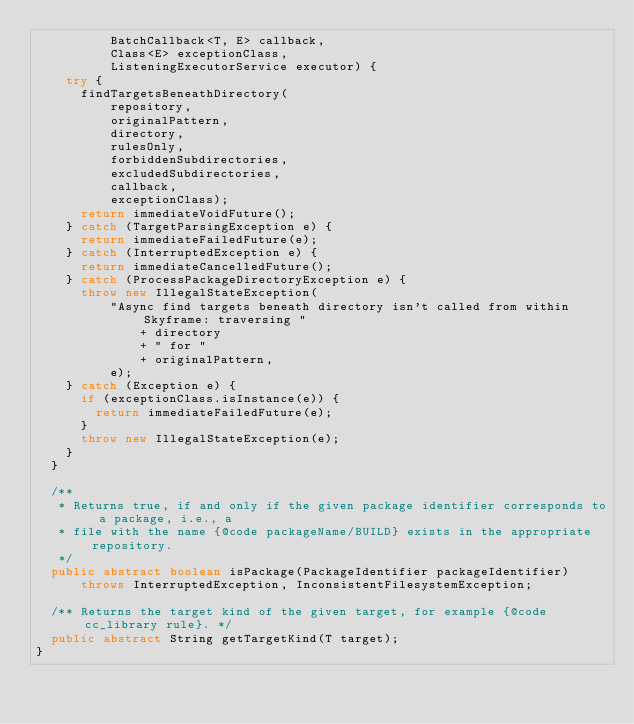Convert code to text. <code><loc_0><loc_0><loc_500><loc_500><_Java_>          BatchCallback<T, E> callback,
          Class<E> exceptionClass,
          ListeningExecutorService executor) {
    try {
      findTargetsBeneathDirectory(
          repository,
          originalPattern,
          directory,
          rulesOnly,
          forbiddenSubdirectories,
          excludedSubdirectories,
          callback,
          exceptionClass);
      return immediateVoidFuture();
    } catch (TargetParsingException e) {
      return immediateFailedFuture(e);
    } catch (InterruptedException e) {
      return immediateCancelledFuture();
    } catch (ProcessPackageDirectoryException e) {
      throw new IllegalStateException(
          "Async find targets beneath directory isn't called from within Skyframe: traversing "
              + directory
              + " for "
              + originalPattern,
          e);
    } catch (Exception e) {
      if (exceptionClass.isInstance(e)) {
        return immediateFailedFuture(e);
      }
      throw new IllegalStateException(e);
    }
  }

  /**
   * Returns true, if and only if the given package identifier corresponds to a package, i.e., a
   * file with the name {@code packageName/BUILD} exists in the appropriate repository.
   */
  public abstract boolean isPackage(PackageIdentifier packageIdentifier)
      throws InterruptedException, InconsistentFilesystemException;

  /** Returns the target kind of the given target, for example {@code cc_library rule}. */
  public abstract String getTargetKind(T target);
}
</code> 